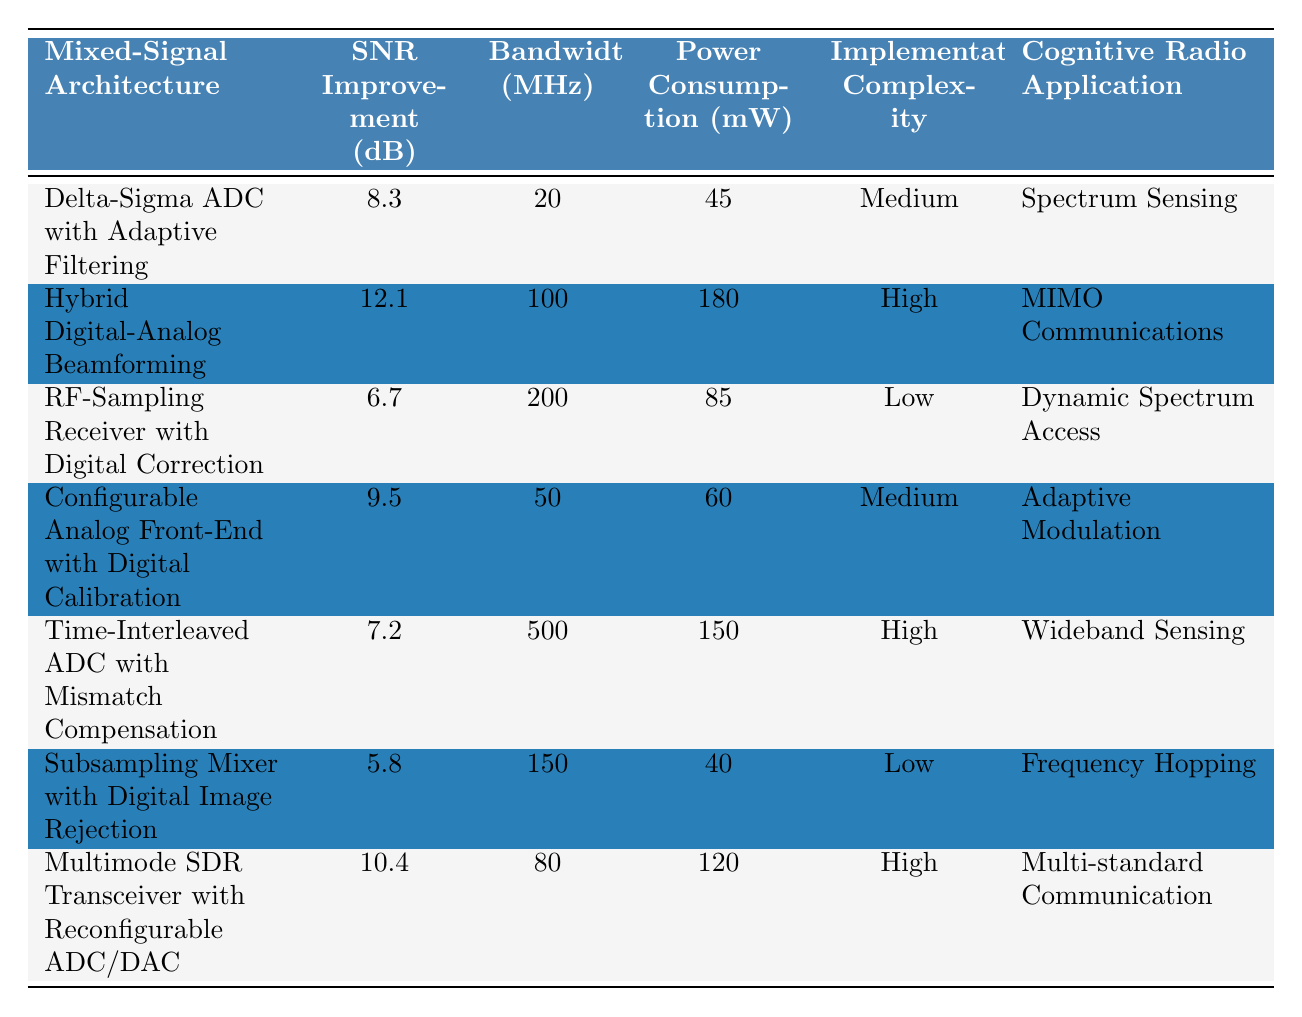What is the SNR improvement for Hybrid Digital-Analog Beamforming? The table shows the SNR improvement for Hybrid Digital-Analog Beamforming is listed as 12.1 dB.
Answer: 12.1 dB Which mixed-signal architecture has the lowest power consumption? The Subsampling Mixer with Digital Image Rejection has the lowest power consumption at 40 mW, as indicated by comparing the values in the Power Consumption column.
Answer: 40 mW What is the average SNR improvement of the architectures listed? To find the average, sum the SNR improvements (8.3 + 12.1 + 6.7 + 9.5 + 7.2 + 5.8 + 10.4 = 59.0 dB) and divide by the number of architectures (7), so the average is 59.0 / 7 = 8.43 dB.
Answer: 8.43 dB Does any architecture have both high power consumption and high implementation complexity? Yes, two architectures have been listed with high power consumption and high implementation complexity: Hybrid Digital-Analog Beamforming (180 mW) and Multimode SDR Transceiver with Reconfigurable ADC/DAC (120 mW).
Answer: Yes Which architecture has the highest SNR improvement and is also suitable for MIMO communications? The Hybrid Digital-Analog Beamforming has the highest SNR improvement at 12.1 dB and is specifically marked for MIMO communications.
Answer: Hybrid Digital-Analog Beamforming What is the difference in SNR improvement between Time-Interleaved ADC with Mismatch Compensation and RF-Sampling Receiver with Digital Correction? The SNR improvement for Time-Interleaved ADC with Mismatch Compensation is 7.2 dB and for RF-Sampling Receiver with Digital Correction is 6.7 dB. The difference is 7.2 - 6.7 = 0.5 dB.
Answer: 0.5 dB Are there any architectures specifically designed for frequency hopping? Yes, the Subsampling Mixer with Digital Image Rejection is designed specifically for frequency hopping, according to the Cognitive Radio Application column.
Answer: Yes How many architectures have a bandwidth of 100 MHz or more? The architectures with bandwidths of 100 MHz or more are Hybrid Digital-Analog Beamforming (100 MHz), RF-Sampling Receiver with Digital Correction (200 MHz), and Time-Interleaved ADC with Mismatch Compensation (500 MHz). That totals three architectures.
Answer: 3 